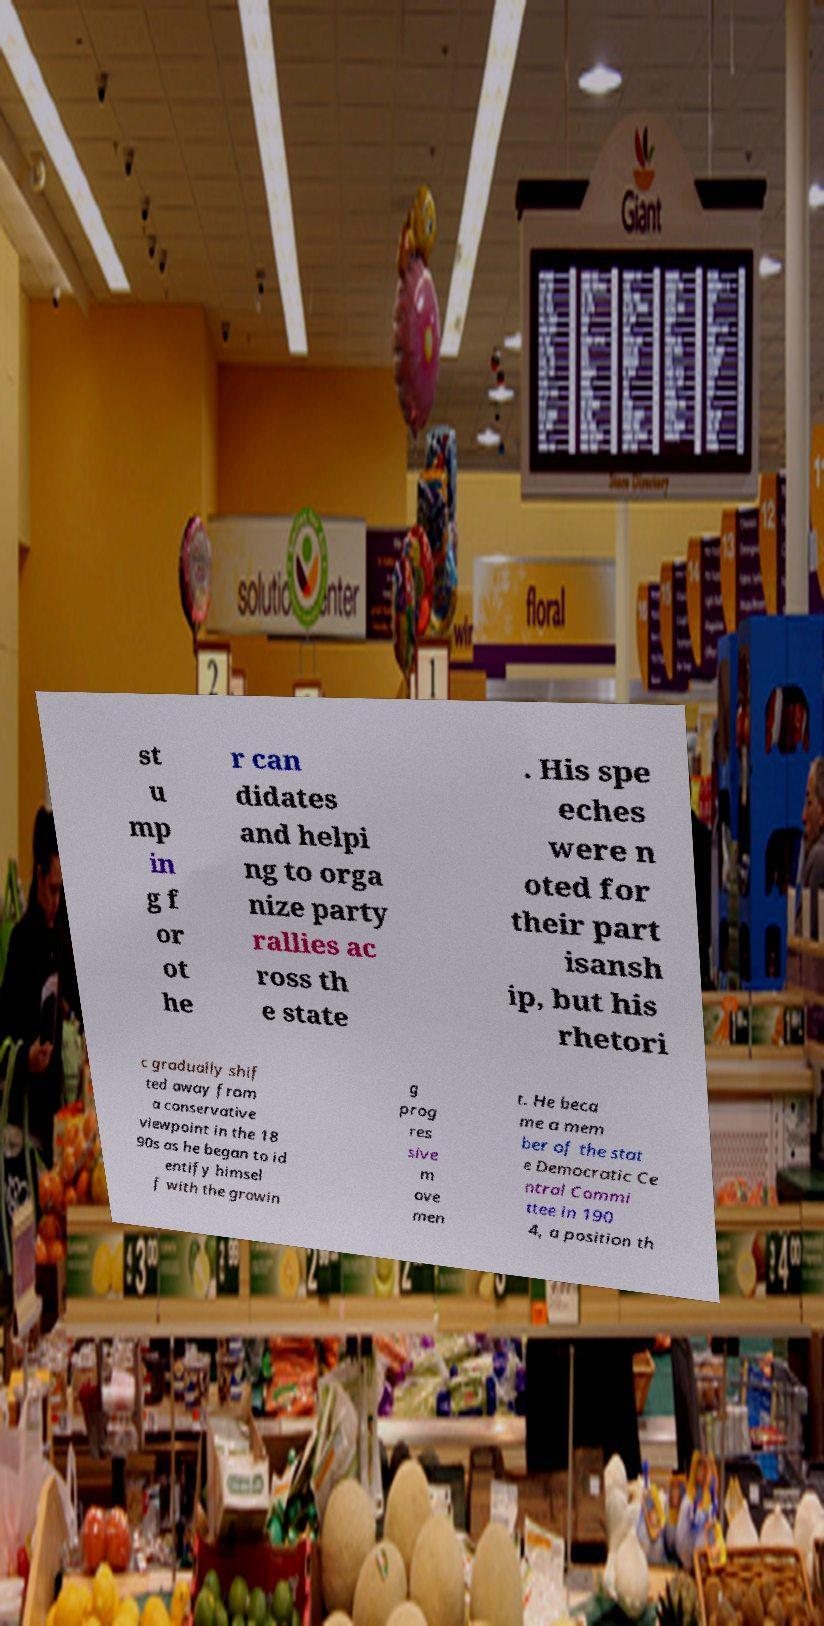Please read and relay the text visible in this image. What does it say? st u mp in g f or ot he r can didates and helpi ng to orga nize party rallies ac ross th e state . His spe eches were n oted for their part isansh ip, but his rhetori c gradually shif ted away from a conservative viewpoint in the 18 90s as he began to id entify himsel f with the growin g prog res sive m ove men t. He beca me a mem ber of the stat e Democratic Ce ntral Commi ttee in 190 4, a position th 